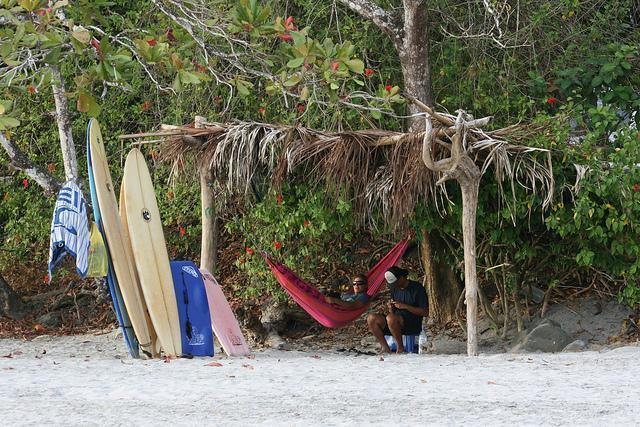What is the person sitting near?
Choose the correct response and explain in the format: 'Answer: answer
Rationale: rationale.'
Options: Hens, cows, surfboards, slippers. Answer: surfboards.
Rationale: There are surfboards stacked up as if for rent. 